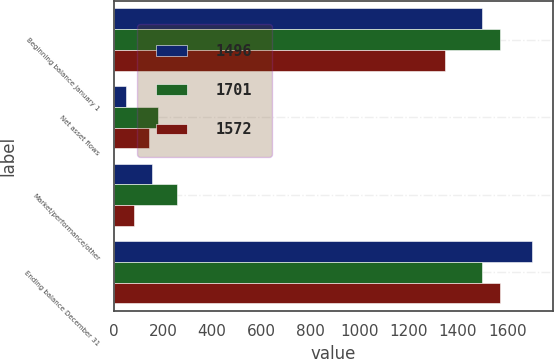<chart> <loc_0><loc_0><loc_500><loc_500><stacked_bar_chart><ecel><fcel>Beginning balance January 1<fcel>Net asset flows<fcel>Market/performance/other<fcel>Ending balance December 31<nl><fcel>1496<fcel>1496<fcel>50<fcel>155<fcel>1701<nl><fcel>1701<fcel>1572<fcel>181<fcel>257<fcel>1496<nl><fcel>1572<fcel>1347<fcel>143<fcel>82<fcel>1572<nl></chart> 